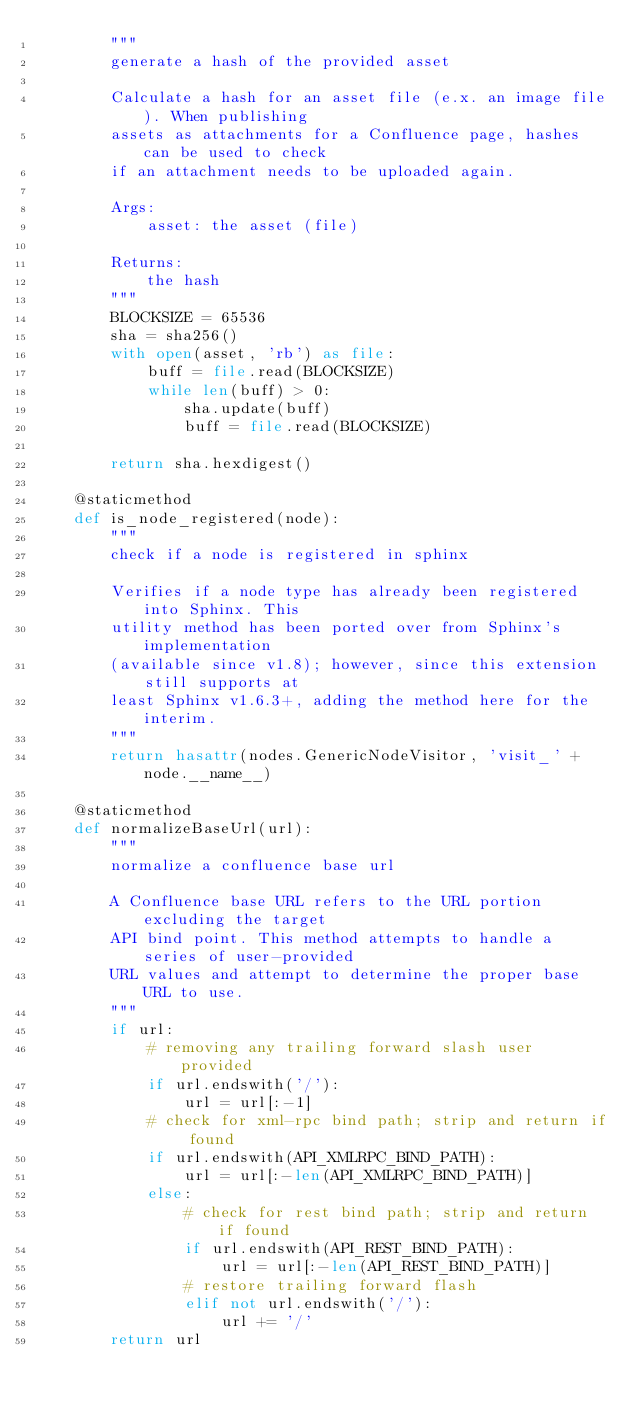Convert code to text. <code><loc_0><loc_0><loc_500><loc_500><_Python_>        """
        generate a hash of the provided asset

        Calculate a hash for an asset file (e.x. an image file). When publishing
        assets as attachments for a Confluence page, hashes can be used to check
        if an attachment needs to be uploaded again.

        Args:
            asset: the asset (file)

        Returns:
            the hash
        """
        BLOCKSIZE = 65536
        sha = sha256()
        with open(asset, 'rb') as file:
            buff = file.read(BLOCKSIZE)
            while len(buff) > 0:
                sha.update(buff)
                buff = file.read(BLOCKSIZE)

        return sha.hexdigest()

    @staticmethod
    def is_node_registered(node):
        """
        check if a node is registered in sphinx

        Verifies if a node type has already been registered into Sphinx. This
        utility method has been ported over from Sphinx's implementation
        (available since v1.8); however, since this extension still supports at
        least Sphinx v1.6.3+, adding the method here for the interim.
        """
        return hasattr(nodes.GenericNodeVisitor, 'visit_' + node.__name__)

    @staticmethod
    def normalizeBaseUrl(url):
        """
        normalize a confluence base url

        A Confluence base URL refers to the URL portion excluding the target
        API bind point. This method attempts to handle a series of user-provided
        URL values and attempt to determine the proper base URL to use.
        """
        if url:
            # removing any trailing forward slash user provided
            if url.endswith('/'):
                url = url[:-1]
            # check for xml-rpc bind path; strip and return if found
            if url.endswith(API_XMLRPC_BIND_PATH):
                url = url[:-len(API_XMLRPC_BIND_PATH)]
            else:
                # check for rest bind path; strip and return if found
                if url.endswith(API_REST_BIND_PATH):
                    url = url[:-len(API_REST_BIND_PATH)]
                # restore trailing forward flash
                elif not url.endswith('/'):
                    url += '/'
        return url
</code> 